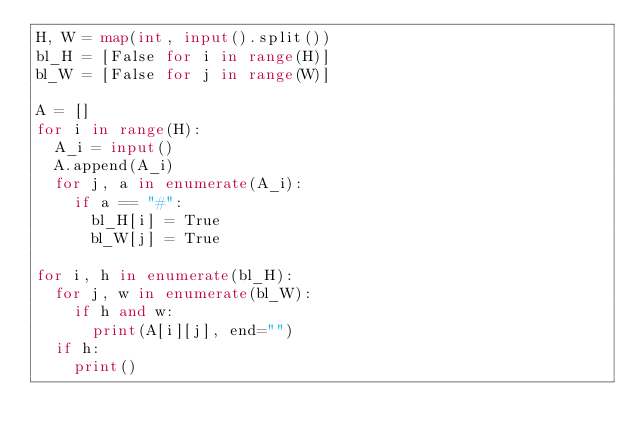<code> <loc_0><loc_0><loc_500><loc_500><_Python_>H, W = map(int, input().split())
bl_H = [False for i in range(H)]
bl_W = [False for j in range(W)]

A = []
for i in range(H):
  A_i = input()
  A.append(A_i)
  for j, a in enumerate(A_i):
    if a == "#":
      bl_H[i] = True
      bl_W[j] = True

for i, h in enumerate(bl_H):
  for j, w in enumerate(bl_W):
    if h and w:
      print(A[i][j], end="")
  if h:
    print()  
</code> 